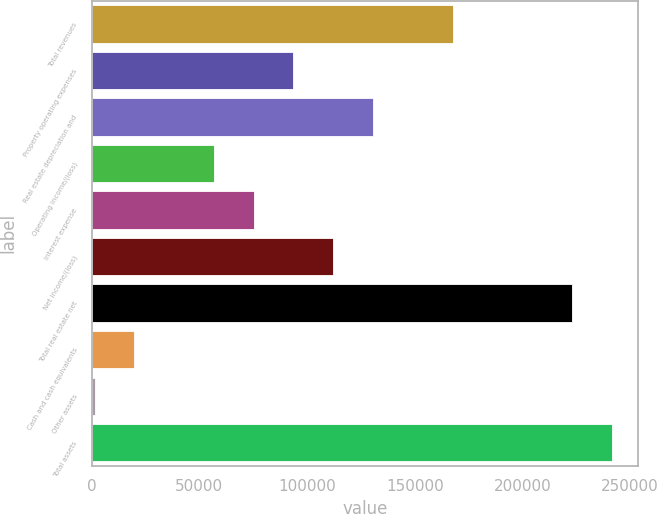<chart> <loc_0><loc_0><loc_500><loc_500><bar_chart><fcel>Total revenues<fcel>Property operating expenses<fcel>Real estate depreciation and<fcel>Operating income/(loss)<fcel>Interest expense<fcel>Net income/(loss)<fcel>Total real estate net<fcel>Cash and cash equivalents<fcel>Other assets<fcel>Total assets<nl><fcel>167608<fcel>93702<fcel>130655<fcel>56749.2<fcel>75225.6<fcel>112178<fcel>223037<fcel>19796.4<fcel>1320<fcel>241513<nl></chart> 